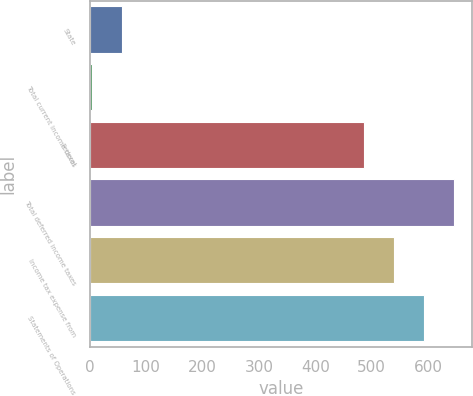<chart> <loc_0><loc_0><loc_500><loc_500><bar_chart><fcel>State<fcel>Total current income taxes<fcel>Federal<fcel>Total deferred income taxes<fcel>Income tax expense from<fcel>Statements of Operations<nl><fcel>57.2<fcel>4<fcel>486<fcel>645.6<fcel>539.2<fcel>592.4<nl></chart> 